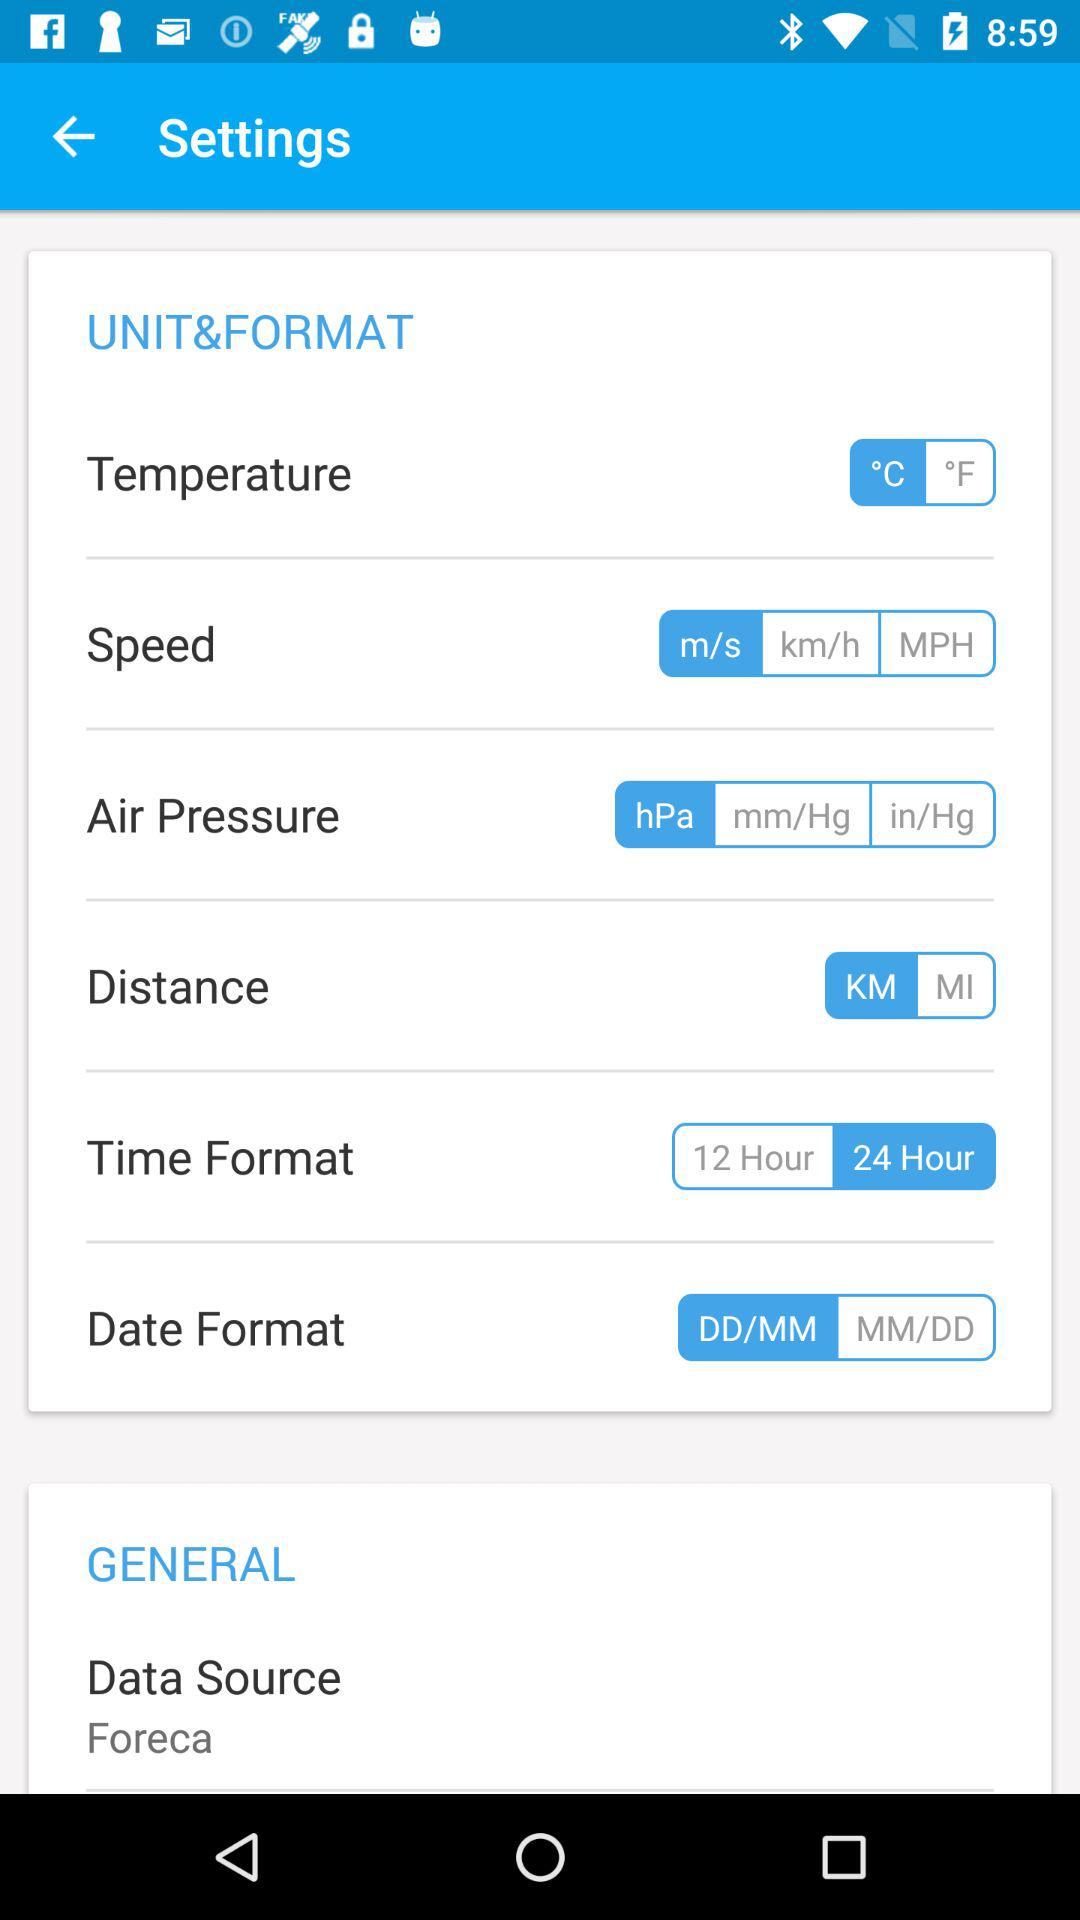Which unit of temperature is selected? The selected unit is °C. 